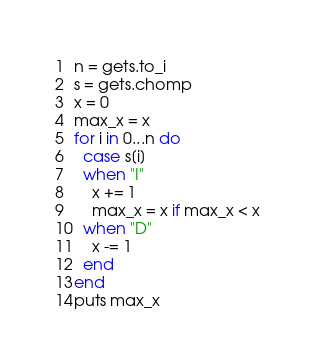<code> <loc_0><loc_0><loc_500><loc_500><_Ruby_>n = gets.to_i
s = gets.chomp
x = 0
max_x = x
for i in 0...n do
  case s[i]
  when "I"
    x += 1
    max_x = x if max_x < x
  when "D"
    x -= 1
  end
end
puts max_x
</code> 